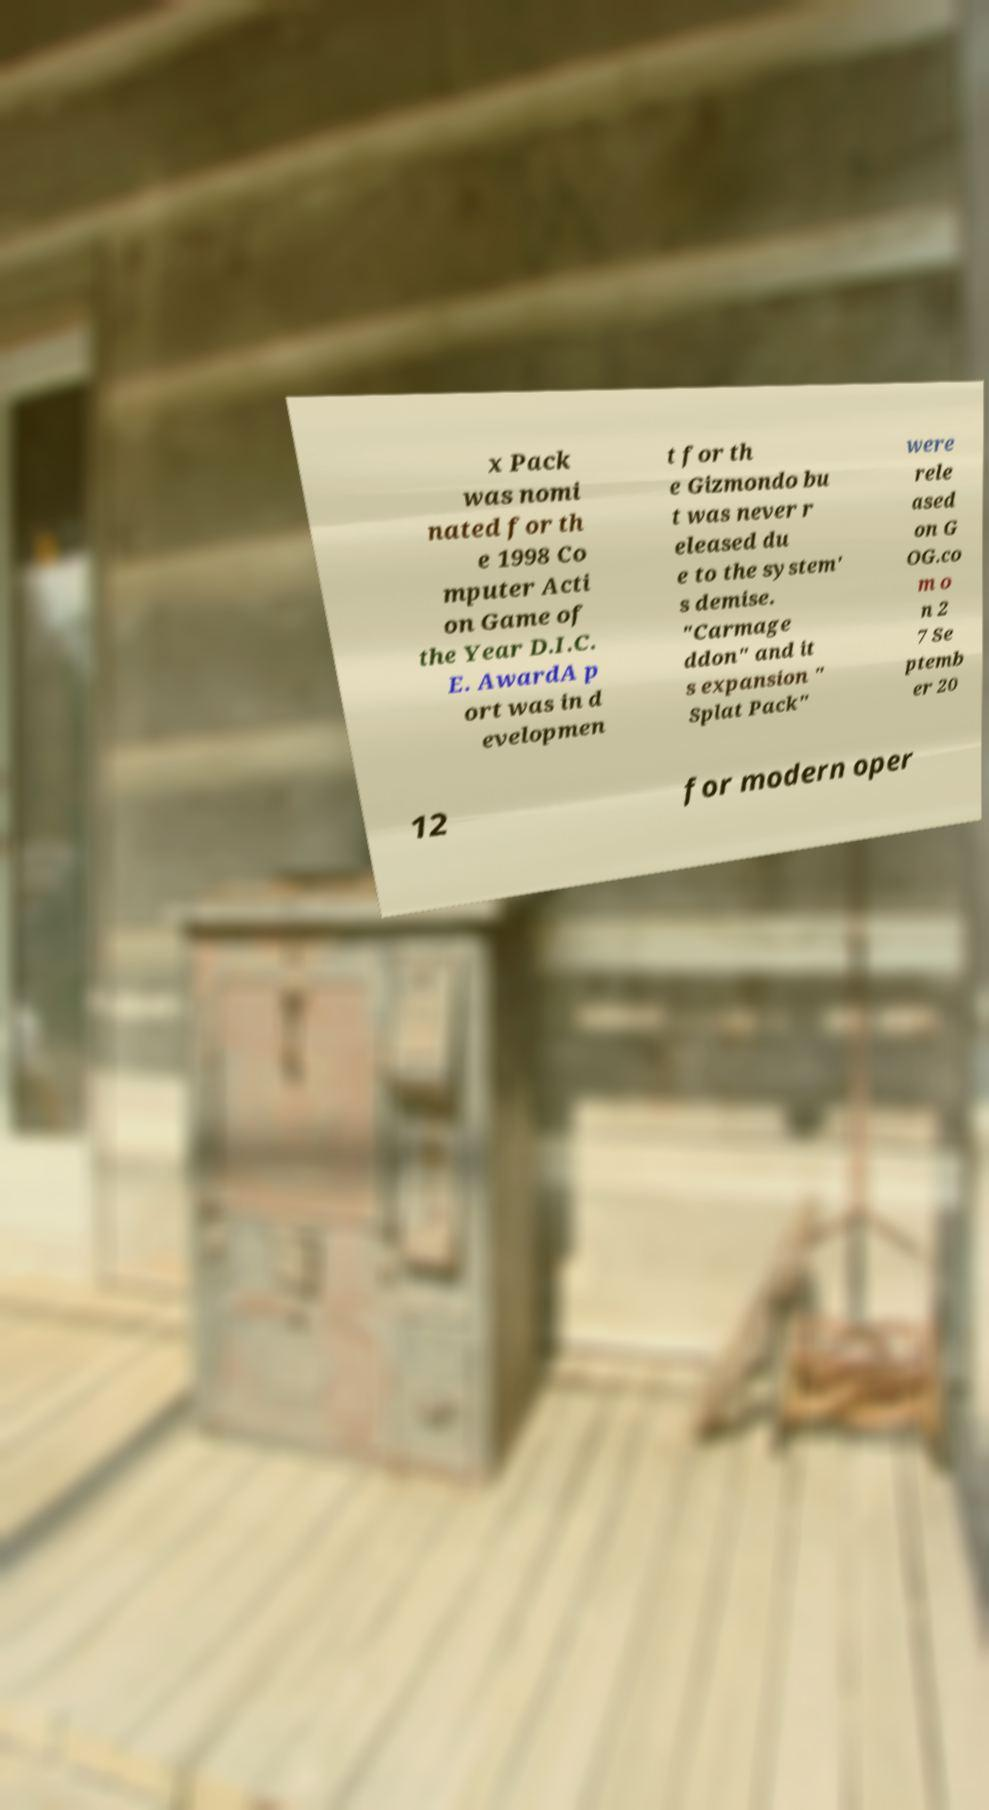Please identify and transcribe the text found in this image. x Pack was nomi nated for th e 1998 Co mputer Acti on Game of the Year D.I.C. E. AwardA p ort was in d evelopmen t for th e Gizmondo bu t was never r eleased du e to the system' s demise. "Carmage ddon" and it s expansion " Splat Pack" were rele ased on G OG.co m o n 2 7 Se ptemb er 20 12 for modern oper 